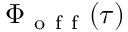<formula> <loc_0><loc_0><loc_500><loc_500>\Phi _ { o f f } ( \tau )</formula> 